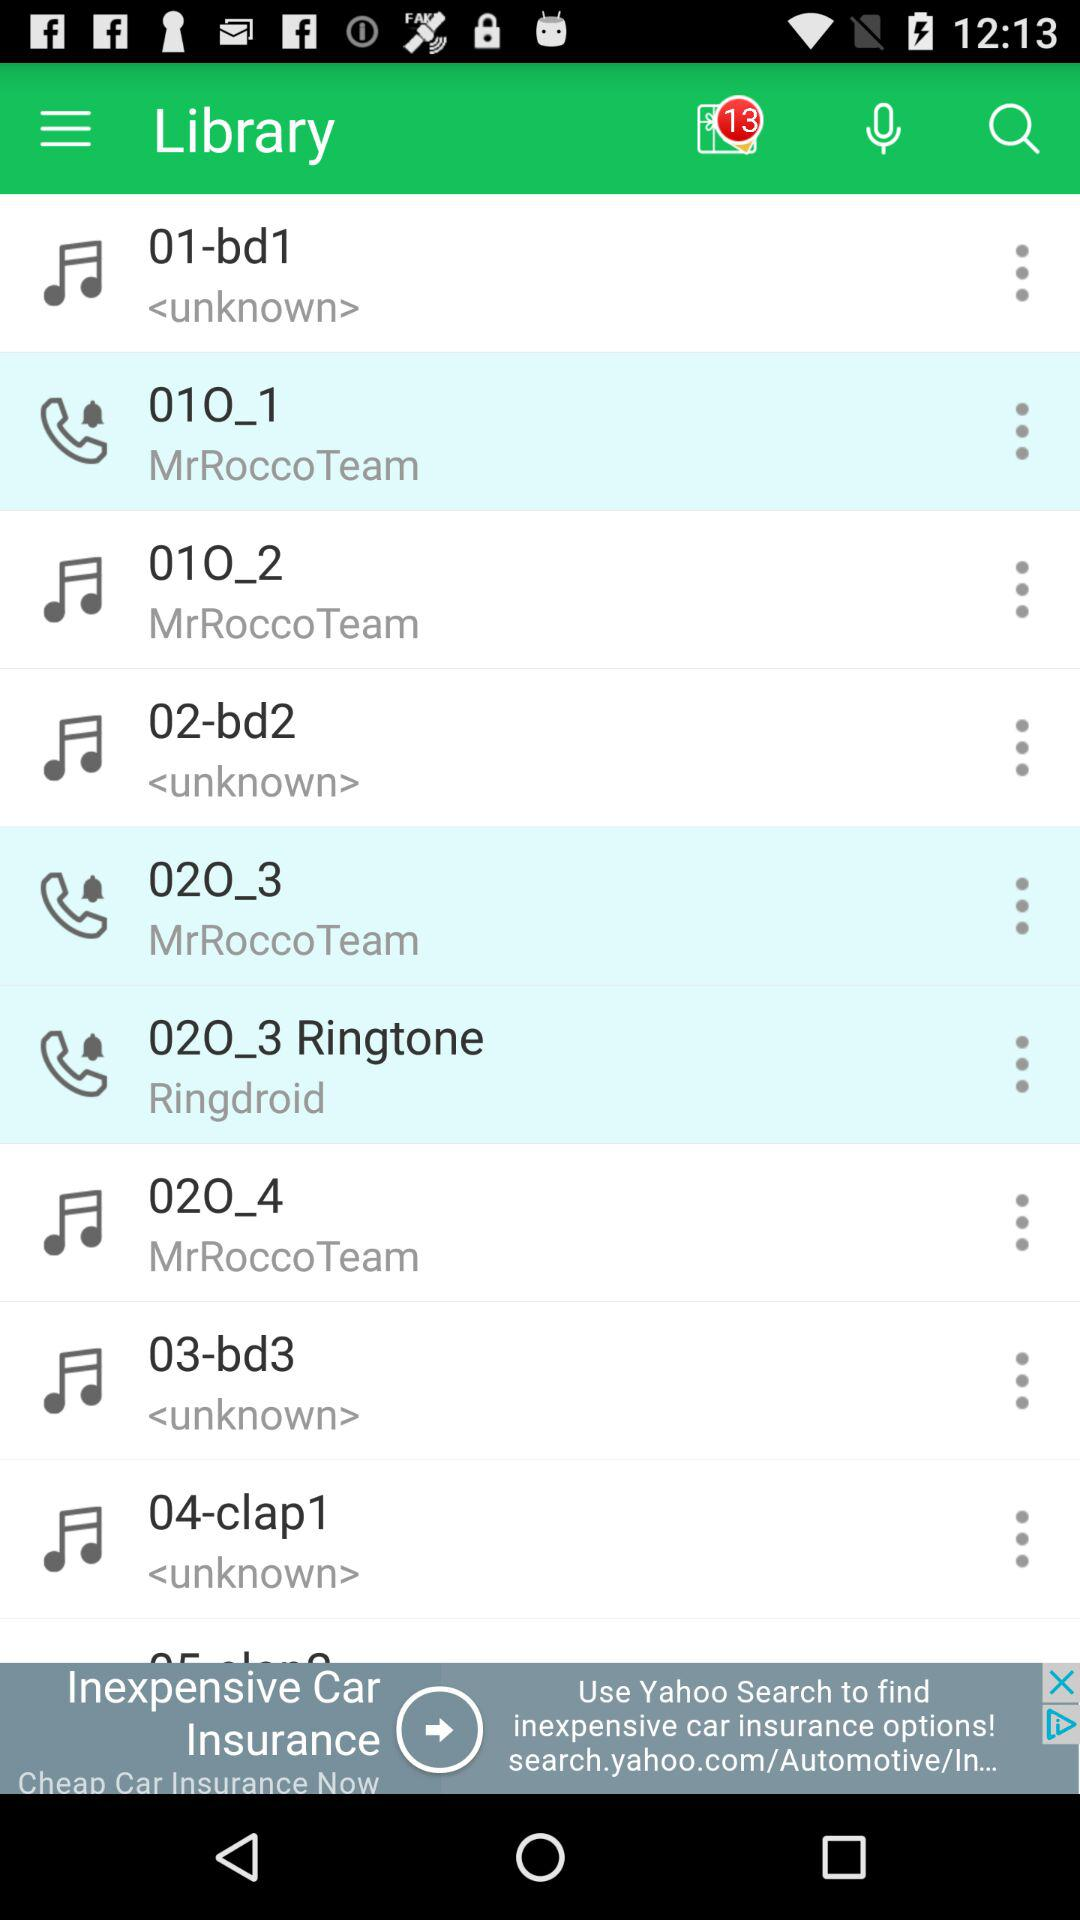How many unread notifications are there? There are 13 unread notifications. 